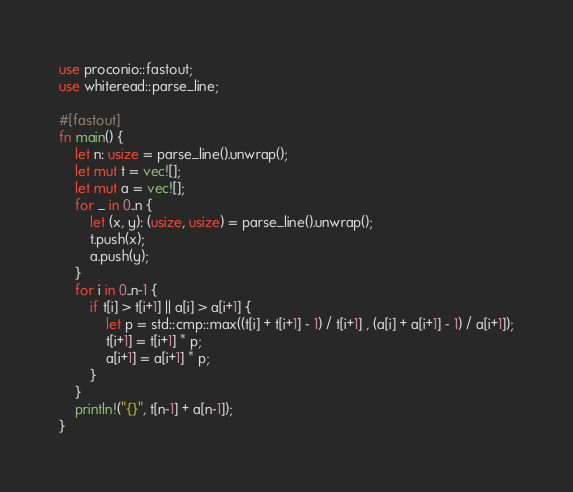<code> <loc_0><loc_0><loc_500><loc_500><_Rust_>use proconio::fastout;
use whiteread::parse_line;

#[fastout]
fn main() {
    let n: usize = parse_line().unwrap();
    let mut t = vec![];
    let mut a = vec![];
    for _ in 0..n {
        let (x, y): (usize, usize) = parse_line().unwrap();
        t.push(x);
        a.push(y);
    }
    for i in 0..n-1 {
        if t[i] > t[i+1] || a[i] > a[i+1] {
            let p = std::cmp::max((t[i] + t[i+1] - 1) / t[i+1] , (a[i] + a[i+1] - 1) / a[i+1]);
            t[i+1] = t[i+1] * p;
            a[i+1] = a[i+1] * p;
        }
    }
    println!("{}", t[n-1] + a[n-1]);
}</code> 